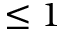Convert formula to latex. <formula><loc_0><loc_0><loc_500><loc_500>\leq 1</formula> 